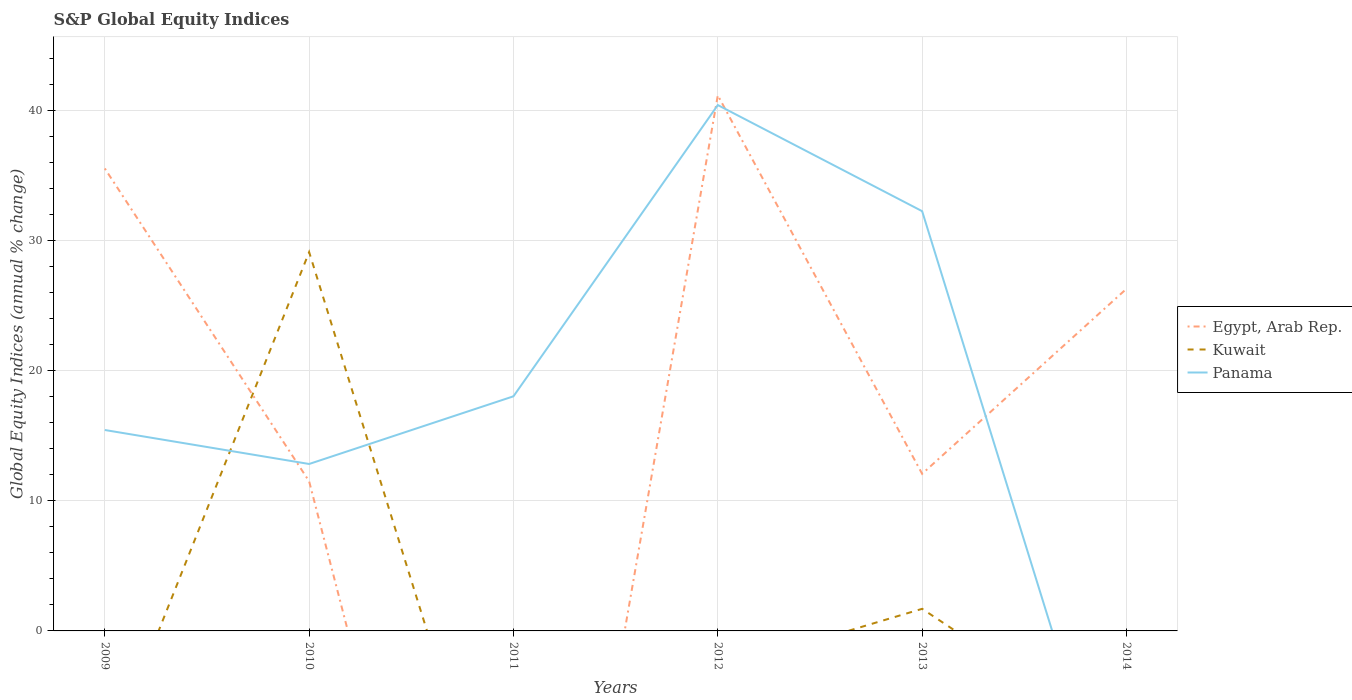How many different coloured lines are there?
Ensure brevity in your answer.  3. Does the line corresponding to Kuwait intersect with the line corresponding to Egypt, Arab Rep.?
Give a very brief answer. Yes. Is the number of lines equal to the number of legend labels?
Make the answer very short. No. Across all years, what is the maximum global equity indices in Egypt, Arab Rep.?
Give a very brief answer. 0. What is the total global equity indices in Egypt, Arab Rep. in the graph?
Provide a succinct answer. 23.48. What is the difference between the highest and the second highest global equity indices in Egypt, Arab Rep.?
Your answer should be very brief. 41.18. What is the difference between the highest and the lowest global equity indices in Egypt, Arab Rep.?
Ensure brevity in your answer.  3. How many lines are there?
Your answer should be very brief. 3. How many years are there in the graph?
Offer a very short reply. 6. What is the difference between two consecutive major ticks on the Y-axis?
Ensure brevity in your answer.  10. Are the values on the major ticks of Y-axis written in scientific E-notation?
Provide a succinct answer. No. Does the graph contain any zero values?
Your answer should be compact. Yes. Does the graph contain grids?
Keep it short and to the point. Yes. Where does the legend appear in the graph?
Ensure brevity in your answer.  Center right. How are the legend labels stacked?
Your answer should be compact. Vertical. What is the title of the graph?
Make the answer very short. S&P Global Equity Indices. Does "Algeria" appear as one of the legend labels in the graph?
Your answer should be compact. No. What is the label or title of the X-axis?
Provide a short and direct response. Years. What is the label or title of the Y-axis?
Your answer should be very brief. Global Equity Indices (annual % change). What is the Global Equity Indices (annual % change) of Egypt, Arab Rep. in 2009?
Your answer should be very brief. 35.55. What is the Global Equity Indices (annual % change) in Kuwait in 2009?
Offer a terse response. 0. What is the Global Equity Indices (annual % change) of Panama in 2009?
Your answer should be very brief. 15.45. What is the Global Equity Indices (annual % change) in Egypt, Arab Rep. in 2010?
Ensure brevity in your answer.  11.5. What is the Global Equity Indices (annual % change) in Kuwait in 2010?
Keep it short and to the point. 29.12. What is the Global Equity Indices (annual % change) of Panama in 2010?
Ensure brevity in your answer.  12.83. What is the Global Equity Indices (annual % change) in Panama in 2011?
Offer a terse response. 18.04. What is the Global Equity Indices (annual % change) in Egypt, Arab Rep. in 2012?
Offer a very short reply. 41.18. What is the Global Equity Indices (annual % change) in Panama in 2012?
Offer a terse response. 40.43. What is the Global Equity Indices (annual % change) in Egypt, Arab Rep. in 2013?
Offer a very short reply. 12.08. What is the Global Equity Indices (annual % change) in Kuwait in 2013?
Your response must be concise. 1.7. What is the Global Equity Indices (annual % change) in Panama in 2013?
Offer a very short reply. 32.27. What is the Global Equity Indices (annual % change) of Egypt, Arab Rep. in 2014?
Make the answer very short. 26.3. What is the Global Equity Indices (annual % change) in Panama in 2014?
Offer a very short reply. 0. Across all years, what is the maximum Global Equity Indices (annual % change) in Egypt, Arab Rep.?
Offer a terse response. 41.18. Across all years, what is the maximum Global Equity Indices (annual % change) of Kuwait?
Offer a terse response. 29.12. Across all years, what is the maximum Global Equity Indices (annual % change) in Panama?
Provide a succinct answer. 40.43. Across all years, what is the minimum Global Equity Indices (annual % change) of Kuwait?
Make the answer very short. 0. Across all years, what is the minimum Global Equity Indices (annual % change) in Panama?
Offer a terse response. 0. What is the total Global Equity Indices (annual % change) in Egypt, Arab Rep. in the graph?
Ensure brevity in your answer.  126.61. What is the total Global Equity Indices (annual % change) in Kuwait in the graph?
Ensure brevity in your answer.  30.82. What is the total Global Equity Indices (annual % change) of Panama in the graph?
Make the answer very short. 119.02. What is the difference between the Global Equity Indices (annual % change) in Egypt, Arab Rep. in 2009 and that in 2010?
Make the answer very short. 24.05. What is the difference between the Global Equity Indices (annual % change) of Panama in 2009 and that in 2010?
Provide a short and direct response. 2.61. What is the difference between the Global Equity Indices (annual % change) in Panama in 2009 and that in 2011?
Ensure brevity in your answer.  -2.59. What is the difference between the Global Equity Indices (annual % change) in Egypt, Arab Rep. in 2009 and that in 2012?
Your answer should be very brief. -5.62. What is the difference between the Global Equity Indices (annual % change) in Panama in 2009 and that in 2012?
Provide a short and direct response. -24.98. What is the difference between the Global Equity Indices (annual % change) in Egypt, Arab Rep. in 2009 and that in 2013?
Keep it short and to the point. 23.48. What is the difference between the Global Equity Indices (annual % change) in Panama in 2009 and that in 2013?
Provide a succinct answer. -16.82. What is the difference between the Global Equity Indices (annual % change) of Egypt, Arab Rep. in 2009 and that in 2014?
Your answer should be compact. 9.25. What is the difference between the Global Equity Indices (annual % change) in Panama in 2010 and that in 2011?
Your answer should be very brief. -5.2. What is the difference between the Global Equity Indices (annual % change) of Egypt, Arab Rep. in 2010 and that in 2012?
Keep it short and to the point. -29.68. What is the difference between the Global Equity Indices (annual % change) in Panama in 2010 and that in 2012?
Provide a short and direct response. -27.59. What is the difference between the Global Equity Indices (annual % change) of Egypt, Arab Rep. in 2010 and that in 2013?
Ensure brevity in your answer.  -0.58. What is the difference between the Global Equity Indices (annual % change) of Kuwait in 2010 and that in 2013?
Ensure brevity in your answer.  27.43. What is the difference between the Global Equity Indices (annual % change) of Panama in 2010 and that in 2013?
Offer a very short reply. -19.44. What is the difference between the Global Equity Indices (annual % change) of Egypt, Arab Rep. in 2010 and that in 2014?
Your answer should be compact. -14.8. What is the difference between the Global Equity Indices (annual % change) of Panama in 2011 and that in 2012?
Keep it short and to the point. -22.39. What is the difference between the Global Equity Indices (annual % change) in Panama in 2011 and that in 2013?
Your answer should be very brief. -14.23. What is the difference between the Global Equity Indices (annual % change) in Egypt, Arab Rep. in 2012 and that in 2013?
Your answer should be very brief. 29.1. What is the difference between the Global Equity Indices (annual % change) in Panama in 2012 and that in 2013?
Offer a terse response. 8.16. What is the difference between the Global Equity Indices (annual % change) of Egypt, Arab Rep. in 2012 and that in 2014?
Provide a succinct answer. 14.88. What is the difference between the Global Equity Indices (annual % change) in Egypt, Arab Rep. in 2013 and that in 2014?
Give a very brief answer. -14.22. What is the difference between the Global Equity Indices (annual % change) in Egypt, Arab Rep. in 2009 and the Global Equity Indices (annual % change) in Kuwait in 2010?
Give a very brief answer. 6.43. What is the difference between the Global Equity Indices (annual % change) of Egypt, Arab Rep. in 2009 and the Global Equity Indices (annual % change) of Panama in 2010?
Offer a terse response. 22.72. What is the difference between the Global Equity Indices (annual % change) of Egypt, Arab Rep. in 2009 and the Global Equity Indices (annual % change) of Panama in 2011?
Your response must be concise. 17.52. What is the difference between the Global Equity Indices (annual % change) in Egypt, Arab Rep. in 2009 and the Global Equity Indices (annual % change) in Panama in 2012?
Provide a succinct answer. -4.88. What is the difference between the Global Equity Indices (annual % change) of Egypt, Arab Rep. in 2009 and the Global Equity Indices (annual % change) of Kuwait in 2013?
Ensure brevity in your answer.  33.86. What is the difference between the Global Equity Indices (annual % change) of Egypt, Arab Rep. in 2009 and the Global Equity Indices (annual % change) of Panama in 2013?
Your response must be concise. 3.28. What is the difference between the Global Equity Indices (annual % change) in Egypt, Arab Rep. in 2010 and the Global Equity Indices (annual % change) in Panama in 2011?
Your answer should be compact. -6.54. What is the difference between the Global Equity Indices (annual % change) in Kuwait in 2010 and the Global Equity Indices (annual % change) in Panama in 2011?
Provide a short and direct response. 11.09. What is the difference between the Global Equity Indices (annual % change) of Egypt, Arab Rep. in 2010 and the Global Equity Indices (annual % change) of Panama in 2012?
Your answer should be very brief. -28.93. What is the difference between the Global Equity Indices (annual % change) of Kuwait in 2010 and the Global Equity Indices (annual % change) of Panama in 2012?
Offer a terse response. -11.31. What is the difference between the Global Equity Indices (annual % change) in Egypt, Arab Rep. in 2010 and the Global Equity Indices (annual % change) in Kuwait in 2013?
Give a very brief answer. 9.8. What is the difference between the Global Equity Indices (annual % change) in Egypt, Arab Rep. in 2010 and the Global Equity Indices (annual % change) in Panama in 2013?
Ensure brevity in your answer.  -20.77. What is the difference between the Global Equity Indices (annual % change) of Kuwait in 2010 and the Global Equity Indices (annual % change) of Panama in 2013?
Your response must be concise. -3.15. What is the difference between the Global Equity Indices (annual % change) in Egypt, Arab Rep. in 2012 and the Global Equity Indices (annual % change) in Kuwait in 2013?
Make the answer very short. 39.48. What is the difference between the Global Equity Indices (annual % change) in Egypt, Arab Rep. in 2012 and the Global Equity Indices (annual % change) in Panama in 2013?
Offer a very short reply. 8.91. What is the average Global Equity Indices (annual % change) in Egypt, Arab Rep. per year?
Offer a very short reply. 21.1. What is the average Global Equity Indices (annual % change) in Kuwait per year?
Your response must be concise. 5.14. What is the average Global Equity Indices (annual % change) of Panama per year?
Make the answer very short. 19.84. In the year 2009, what is the difference between the Global Equity Indices (annual % change) in Egypt, Arab Rep. and Global Equity Indices (annual % change) in Panama?
Offer a very short reply. 20.11. In the year 2010, what is the difference between the Global Equity Indices (annual % change) in Egypt, Arab Rep. and Global Equity Indices (annual % change) in Kuwait?
Make the answer very short. -17.62. In the year 2010, what is the difference between the Global Equity Indices (annual % change) in Egypt, Arab Rep. and Global Equity Indices (annual % change) in Panama?
Your answer should be compact. -1.33. In the year 2010, what is the difference between the Global Equity Indices (annual % change) of Kuwait and Global Equity Indices (annual % change) of Panama?
Ensure brevity in your answer.  16.29. In the year 2012, what is the difference between the Global Equity Indices (annual % change) in Egypt, Arab Rep. and Global Equity Indices (annual % change) in Panama?
Provide a short and direct response. 0.75. In the year 2013, what is the difference between the Global Equity Indices (annual % change) of Egypt, Arab Rep. and Global Equity Indices (annual % change) of Kuwait?
Keep it short and to the point. 10.38. In the year 2013, what is the difference between the Global Equity Indices (annual % change) of Egypt, Arab Rep. and Global Equity Indices (annual % change) of Panama?
Provide a succinct answer. -20.19. In the year 2013, what is the difference between the Global Equity Indices (annual % change) of Kuwait and Global Equity Indices (annual % change) of Panama?
Keep it short and to the point. -30.57. What is the ratio of the Global Equity Indices (annual % change) of Egypt, Arab Rep. in 2009 to that in 2010?
Provide a short and direct response. 3.09. What is the ratio of the Global Equity Indices (annual % change) in Panama in 2009 to that in 2010?
Make the answer very short. 1.2. What is the ratio of the Global Equity Indices (annual % change) in Panama in 2009 to that in 2011?
Your answer should be compact. 0.86. What is the ratio of the Global Equity Indices (annual % change) in Egypt, Arab Rep. in 2009 to that in 2012?
Offer a very short reply. 0.86. What is the ratio of the Global Equity Indices (annual % change) in Panama in 2009 to that in 2012?
Your response must be concise. 0.38. What is the ratio of the Global Equity Indices (annual % change) in Egypt, Arab Rep. in 2009 to that in 2013?
Offer a very short reply. 2.94. What is the ratio of the Global Equity Indices (annual % change) in Panama in 2009 to that in 2013?
Ensure brevity in your answer.  0.48. What is the ratio of the Global Equity Indices (annual % change) of Egypt, Arab Rep. in 2009 to that in 2014?
Keep it short and to the point. 1.35. What is the ratio of the Global Equity Indices (annual % change) in Panama in 2010 to that in 2011?
Your response must be concise. 0.71. What is the ratio of the Global Equity Indices (annual % change) in Egypt, Arab Rep. in 2010 to that in 2012?
Offer a terse response. 0.28. What is the ratio of the Global Equity Indices (annual % change) of Panama in 2010 to that in 2012?
Your answer should be compact. 0.32. What is the ratio of the Global Equity Indices (annual % change) of Egypt, Arab Rep. in 2010 to that in 2013?
Keep it short and to the point. 0.95. What is the ratio of the Global Equity Indices (annual % change) of Kuwait in 2010 to that in 2013?
Your response must be concise. 17.15. What is the ratio of the Global Equity Indices (annual % change) in Panama in 2010 to that in 2013?
Ensure brevity in your answer.  0.4. What is the ratio of the Global Equity Indices (annual % change) of Egypt, Arab Rep. in 2010 to that in 2014?
Your answer should be very brief. 0.44. What is the ratio of the Global Equity Indices (annual % change) of Panama in 2011 to that in 2012?
Provide a succinct answer. 0.45. What is the ratio of the Global Equity Indices (annual % change) in Panama in 2011 to that in 2013?
Your answer should be very brief. 0.56. What is the ratio of the Global Equity Indices (annual % change) of Egypt, Arab Rep. in 2012 to that in 2013?
Your answer should be compact. 3.41. What is the ratio of the Global Equity Indices (annual % change) of Panama in 2012 to that in 2013?
Give a very brief answer. 1.25. What is the ratio of the Global Equity Indices (annual % change) in Egypt, Arab Rep. in 2012 to that in 2014?
Provide a short and direct response. 1.57. What is the ratio of the Global Equity Indices (annual % change) in Egypt, Arab Rep. in 2013 to that in 2014?
Your answer should be very brief. 0.46. What is the difference between the highest and the second highest Global Equity Indices (annual % change) in Egypt, Arab Rep.?
Keep it short and to the point. 5.62. What is the difference between the highest and the second highest Global Equity Indices (annual % change) in Panama?
Offer a very short reply. 8.16. What is the difference between the highest and the lowest Global Equity Indices (annual % change) in Egypt, Arab Rep.?
Provide a short and direct response. 41.18. What is the difference between the highest and the lowest Global Equity Indices (annual % change) in Kuwait?
Ensure brevity in your answer.  29.12. What is the difference between the highest and the lowest Global Equity Indices (annual % change) in Panama?
Your answer should be compact. 40.43. 